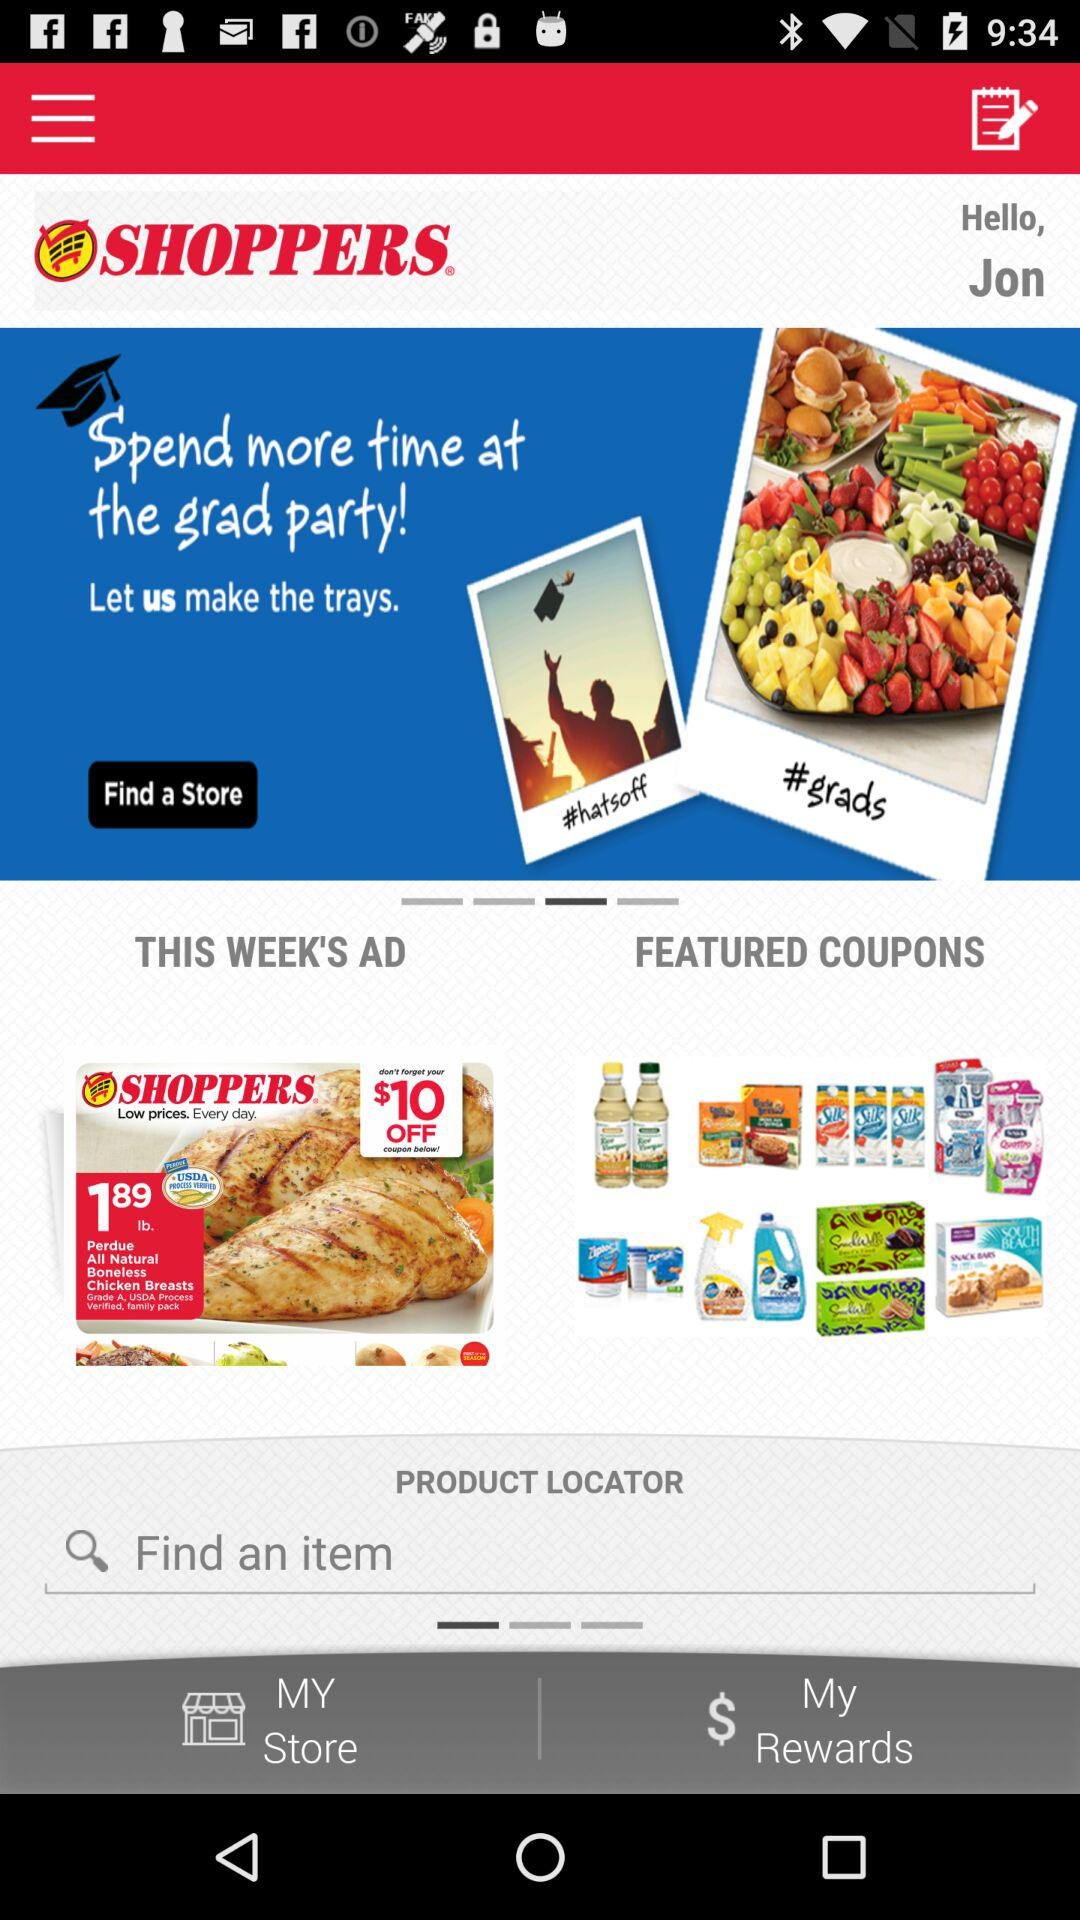What is the app name? The app name is "SHOPPERS.". 